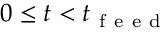<formula> <loc_0><loc_0><loc_500><loc_500>0 \leq t < t _ { f e e d }</formula> 